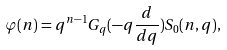<formula> <loc_0><loc_0><loc_500><loc_500>\varphi ( n ) = q ^ { n - 1 } G _ { q } ( - q \frac { d } { d q } ) S _ { 0 } ( n , q ) ,</formula> 